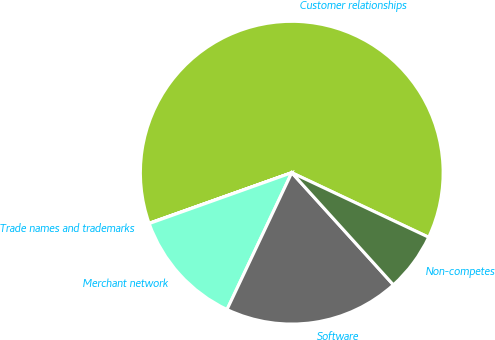Convert chart to OTSL. <chart><loc_0><loc_0><loc_500><loc_500><pie_chart><fcel>Customer relationships<fcel>Trade names and trademarks<fcel>Merchant network<fcel>Software<fcel>Non-competes<nl><fcel>62.43%<fcel>0.03%<fcel>12.51%<fcel>18.75%<fcel>6.27%<nl></chart> 